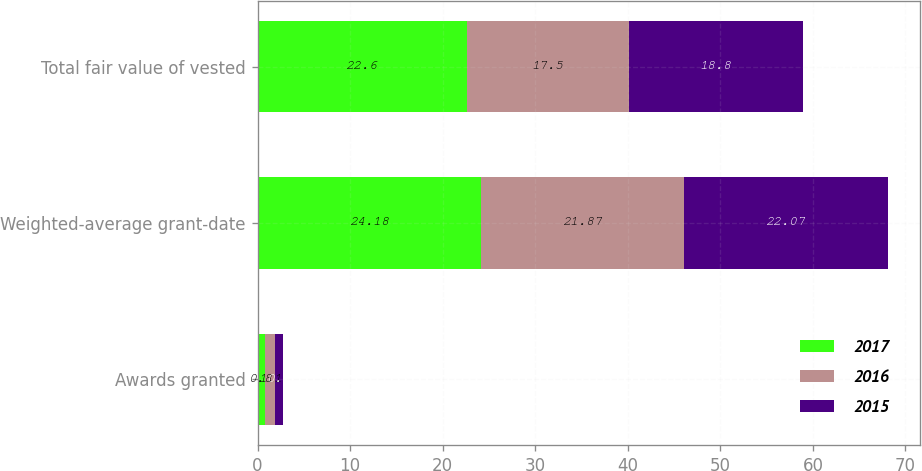Convert chart. <chart><loc_0><loc_0><loc_500><loc_500><stacked_bar_chart><ecel><fcel>Awards granted<fcel>Weighted-average grant-date<fcel>Total fair value of vested<nl><fcel>2017<fcel>0.8<fcel>24.18<fcel>22.6<nl><fcel>2016<fcel>1.1<fcel>21.87<fcel>17.5<nl><fcel>2015<fcel>0.8<fcel>22.07<fcel>18.8<nl></chart> 